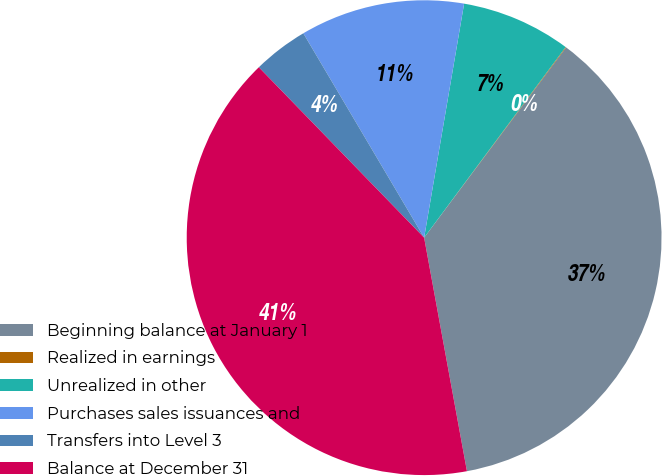Convert chart to OTSL. <chart><loc_0><loc_0><loc_500><loc_500><pie_chart><fcel>Beginning balance at January 1<fcel>Realized in earnings<fcel>Unrealized in other<fcel>Purchases sales issuances and<fcel>Transfers into Level 3<fcel>Balance at December 31<nl><fcel>36.91%<fcel>0.04%<fcel>7.47%<fcel>11.19%<fcel>3.76%<fcel>40.63%<nl></chart> 